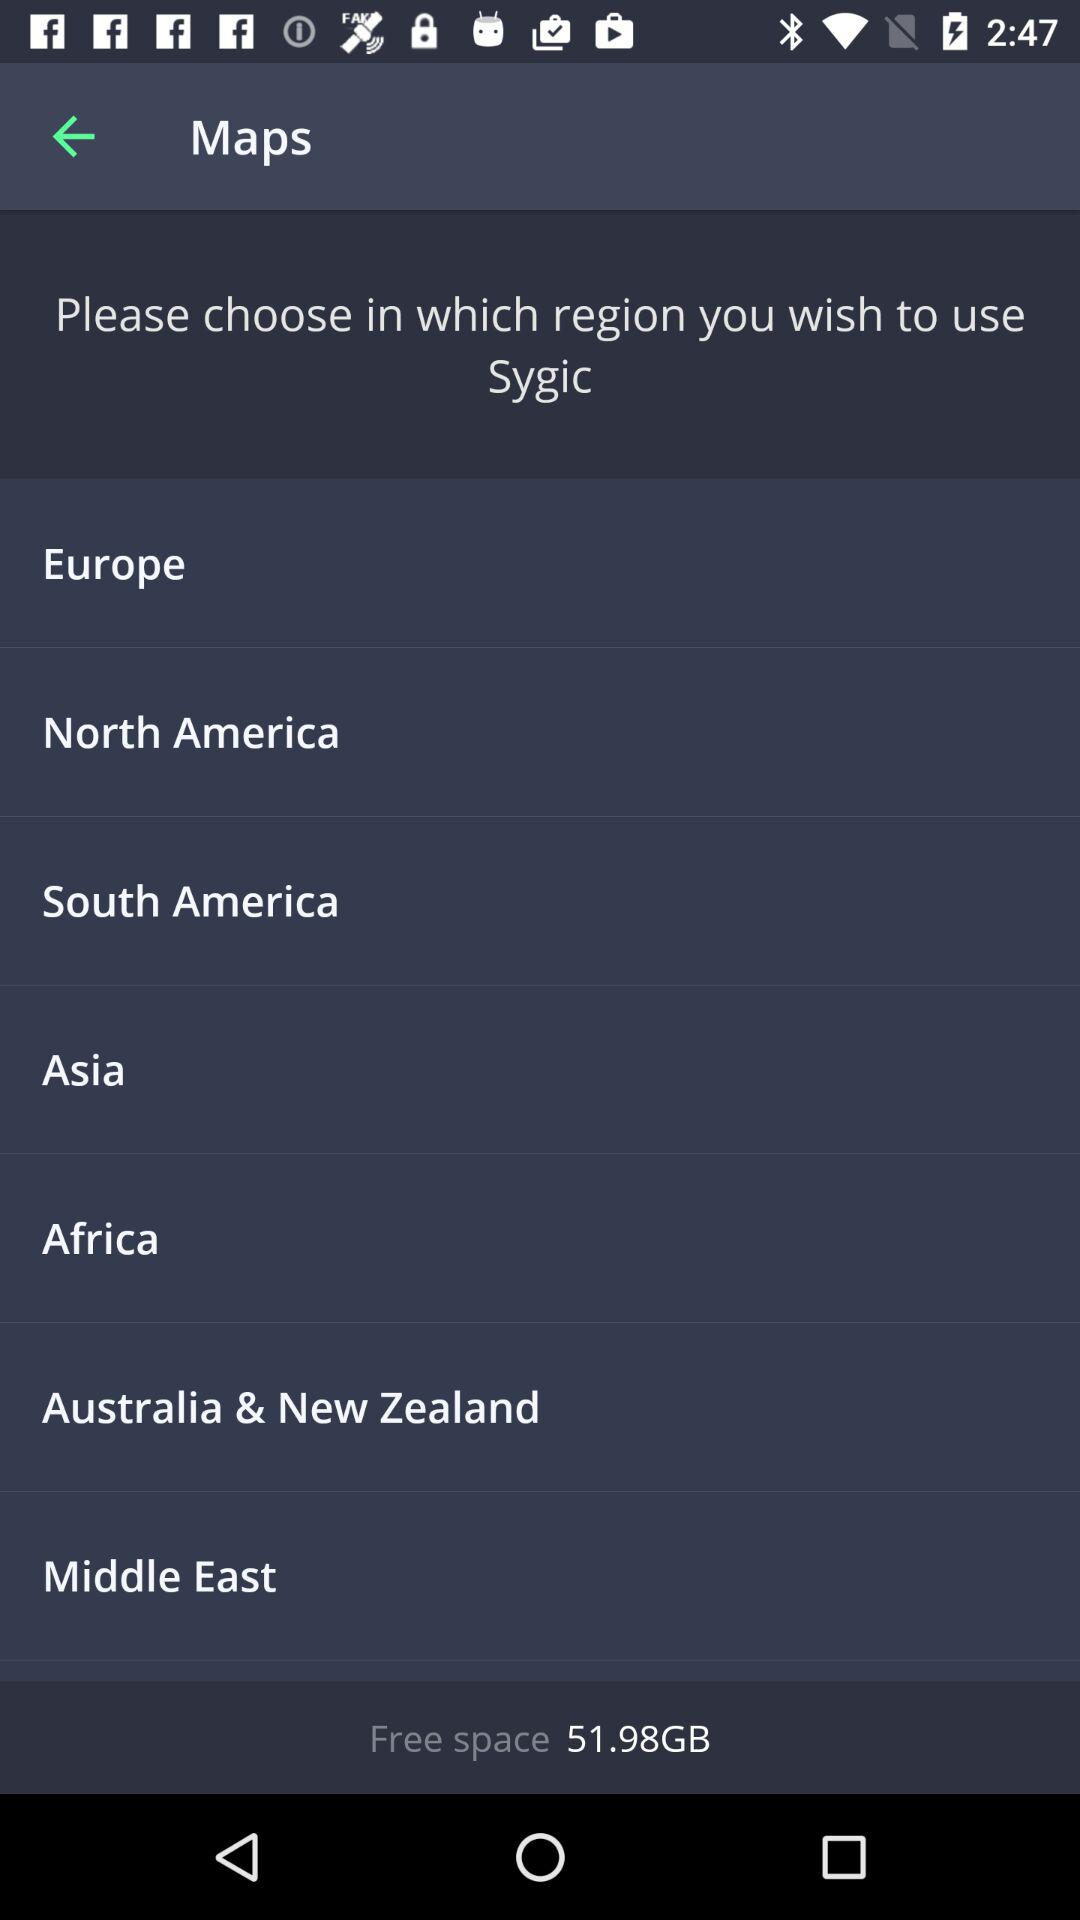Can you tell me what time is displayed on the device? Certainly, the time displayed on the device is 2:47, although it is not specified if it's AM or PM. 